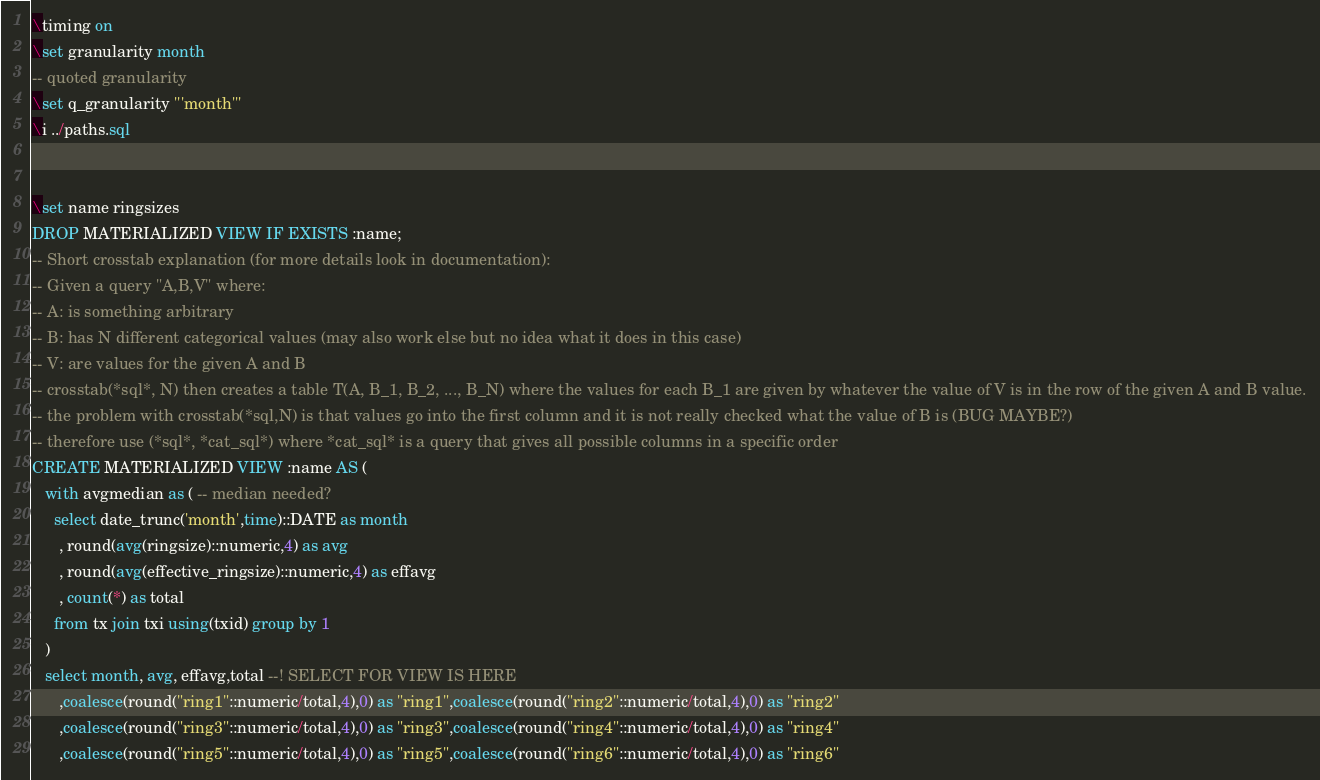Convert code to text. <code><loc_0><loc_0><loc_500><loc_500><_SQL_>\timing on
\set granularity month
-- quoted granularity
\set q_granularity '''month'''
\i ../paths.sql


\set name ringsizes
DROP MATERIALIZED VIEW IF EXISTS :name;
-- Short crosstab explanation (for more details look in documentation):
-- Given a query "A,B,V" where:
-- A: is something arbitrary
-- B: has N different categorical values (may also work else but no idea what it does in this case)
-- V: are values for the given A and B
-- crosstab(*sql*, N) then creates a table T(A, B_1, B_2, ..., B_N) where the values for each B_1 are given by whatever the value of V is in the row of the given A and B value.
-- the problem with crosstab(*sql,N) is that values go into the first column and it is not really checked what the value of B is (BUG MAYBE?)
-- therefore use (*sql*, *cat_sql*) where *cat_sql* is a query that gives all possible columns in a specific order
CREATE MATERIALIZED VIEW :name AS (
   with avgmedian as ( -- median needed?
     select date_trunc('month',time)::DATE as month
      , round(avg(ringsize)::numeric,4) as avg
      , round(avg(effective_ringsize)::numeric,4) as effavg
      , count(*) as total
     from tx join txi using(txid) group by 1
   )
   select month, avg, effavg,total --! SELECT FOR VIEW IS HERE
      ,coalesce(round("ring1"::numeric/total,4),0) as "ring1",coalesce(round("ring2"::numeric/total,4),0) as "ring2"
      ,coalesce(round("ring3"::numeric/total,4),0) as "ring3",coalesce(round("ring4"::numeric/total,4),0) as "ring4"
      ,coalesce(round("ring5"::numeric/total,4),0) as "ring5",coalesce(round("ring6"::numeric/total,4),0) as "ring6"</code> 